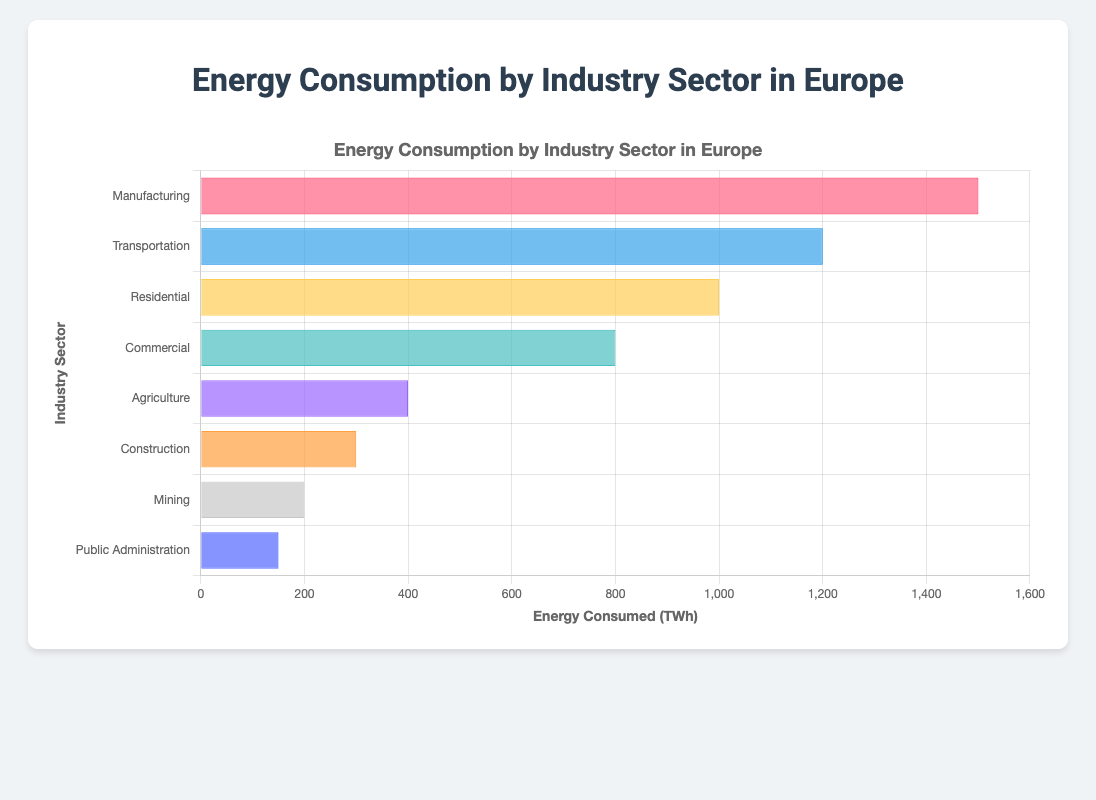Which industry has the highest energy consumption? To determine the highest energy consumption, look for the longest bar in the chart. The Manufacturing industry has the longest bar at 1500 TWh.
Answer: Manufacturing Which industry consumes the least energy? To find the industry with the least energy consumption, identify the shortest bar in the chart. The Public Administration sector has the shortest bar at 150 TWh.
Answer: Public Administration What's the total energy consumption of the top three industries? The top three industries are Manufacturing (1500 TWh), Transportation (1200 TWh), and Residential (1000 TWh). Summing these values: 1500 + 1200 + 1000 = 3700 TWh.
Answer: 3700 TWh Is the energy consumption of the Residential sector greater than that of the Commercial sector? Compare the lengths of the bars for Residential and Commercial. The Residential bar (1000 TWh) is longer than the Commercial bar (800 TWh).
Answer: Yes By how much does the energy consumption of the Transportation sector exceed that of the Agriculture sector? The Transportation sector consumes 1200 TWh, and Agriculture consumes 400 TWh. The difference is 1200 - 400 = 800 TWh.
Answer: 800 TWh What's the average energy consumption across all industries? Sum the energy consumption of all industries and divide by the number of industries: (1500 + 1200 + 1000 + 800 + 400 + 300 + 200 + 150) / 8 = 5550 / 8 = 693.75 TWh.
Answer: 693.75 TWh Which two industries combined consume the same amount of energy as Manufacturing? Identify two sectors whose total energy consumption equals Manufacturing (1500 TWh). Transportation (1200 TWh) and Agriculture (400 TWh) do not match exactly but come closest.
Answer: No exact match What is the median energy consumption value among all industry sectors? Order the energy consumptions: 150, 200, 300, 400, 800, 1000, 1200, 1500. Median is the average of 400 and 800 (positions 4 and 5): (400 + 800) / 2 = 600 TWh.
Answer: 600 TWh 